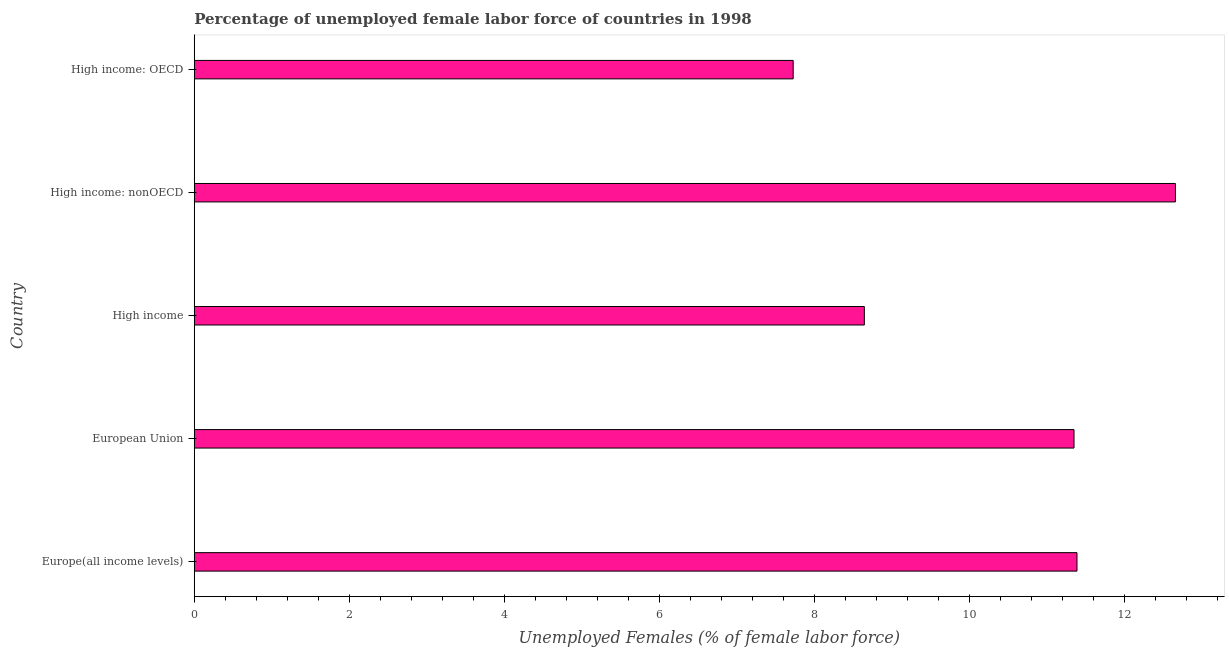Does the graph contain any zero values?
Offer a terse response. No. What is the title of the graph?
Offer a very short reply. Percentage of unemployed female labor force of countries in 1998. What is the label or title of the X-axis?
Offer a very short reply. Unemployed Females (% of female labor force). What is the total unemployed female labour force in High income?
Ensure brevity in your answer.  8.65. Across all countries, what is the maximum total unemployed female labour force?
Provide a succinct answer. 12.66. Across all countries, what is the minimum total unemployed female labour force?
Offer a terse response. 7.73. In which country was the total unemployed female labour force maximum?
Provide a succinct answer. High income: nonOECD. In which country was the total unemployed female labour force minimum?
Offer a terse response. High income: OECD. What is the sum of the total unemployed female labour force?
Ensure brevity in your answer.  51.78. What is the difference between the total unemployed female labour force in Europe(all income levels) and High income?
Give a very brief answer. 2.74. What is the average total unemployed female labour force per country?
Make the answer very short. 10.36. What is the median total unemployed female labour force?
Offer a very short reply. 11.35. In how many countries, is the total unemployed female labour force greater than 3.6 %?
Your response must be concise. 5. What is the ratio of the total unemployed female labour force in European Union to that in High income?
Make the answer very short. 1.31. Is the total unemployed female labour force in Europe(all income levels) less than that in High income: nonOECD?
Provide a succinct answer. Yes. What is the difference between the highest and the second highest total unemployed female labour force?
Give a very brief answer. 1.27. Is the sum of the total unemployed female labour force in Europe(all income levels) and European Union greater than the maximum total unemployed female labour force across all countries?
Your answer should be compact. Yes. What is the difference between the highest and the lowest total unemployed female labour force?
Give a very brief answer. 4.93. How many countries are there in the graph?
Your answer should be very brief. 5. What is the Unemployed Females (% of female labor force) of Europe(all income levels)?
Keep it short and to the point. 11.39. What is the Unemployed Females (% of female labor force) in European Union?
Keep it short and to the point. 11.35. What is the Unemployed Females (% of female labor force) in High income?
Ensure brevity in your answer.  8.65. What is the Unemployed Females (% of female labor force) of High income: nonOECD?
Provide a succinct answer. 12.66. What is the Unemployed Females (% of female labor force) of High income: OECD?
Your response must be concise. 7.73. What is the difference between the Unemployed Females (% of female labor force) in Europe(all income levels) and European Union?
Provide a short and direct response. 0.04. What is the difference between the Unemployed Females (% of female labor force) in Europe(all income levels) and High income?
Provide a succinct answer. 2.74. What is the difference between the Unemployed Females (% of female labor force) in Europe(all income levels) and High income: nonOECD?
Offer a terse response. -1.27. What is the difference between the Unemployed Females (% of female labor force) in Europe(all income levels) and High income: OECD?
Your answer should be compact. 3.66. What is the difference between the Unemployed Females (% of female labor force) in European Union and High income?
Give a very brief answer. 2.71. What is the difference between the Unemployed Females (% of female labor force) in European Union and High income: nonOECD?
Your answer should be compact. -1.31. What is the difference between the Unemployed Females (% of female labor force) in European Union and High income: OECD?
Your response must be concise. 3.62. What is the difference between the Unemployed Females (% of female labor force) in High income and High income: nonOECD?
Offer a very short reply. -4.01. What is the difference between the Unemployed Females (% of female labor force) in High income and High income: OECD?
Your answer should be very brief. 0.92. What is the difference between the Unemployed Females (% of female labor force) in High income: nonOECD and High income: OECD?
Keep it short and to the point. 4.93. What is the ratio of the Unemployed Females (% of female labor force) in Europe(all income levels) to that in High income?
Your answer should be very brief. 1.32. What is the ratio of the Unemployed Females (% of female labor force) in Europe(all income levels) to that in High income: OECD?
Offer a very short reply. 1.47. What is the ratio of the Unemployed Females (% of female labor force) in European Union to that in High income?
Offer a very short reply. 1.31. What is the ratio of the Unemployed Females (% of female labor force) in European Union to that in High income: nonOECD?
Your answer should be very brief. 0.9. What is the ratio of the Unemployed Females (% of female labor force) in European Union to that in High income: OECD?
Offer a terse response. 1.47. What is the ratio of the Unemployed Females (% of female labor force) in High income to that in High income: nonOECD?
Make the answer very short. 0.68. What is the ratio of the Unemployed Females (% of female labor force) in High income to that in High income: OECD?
Keep it short and to the point. 1.12. What is the ratio of the Unemployed Females (% of female labor force) in High income: nonOECD to that in High income: OECD?
Make the answer very short. 1.64. 